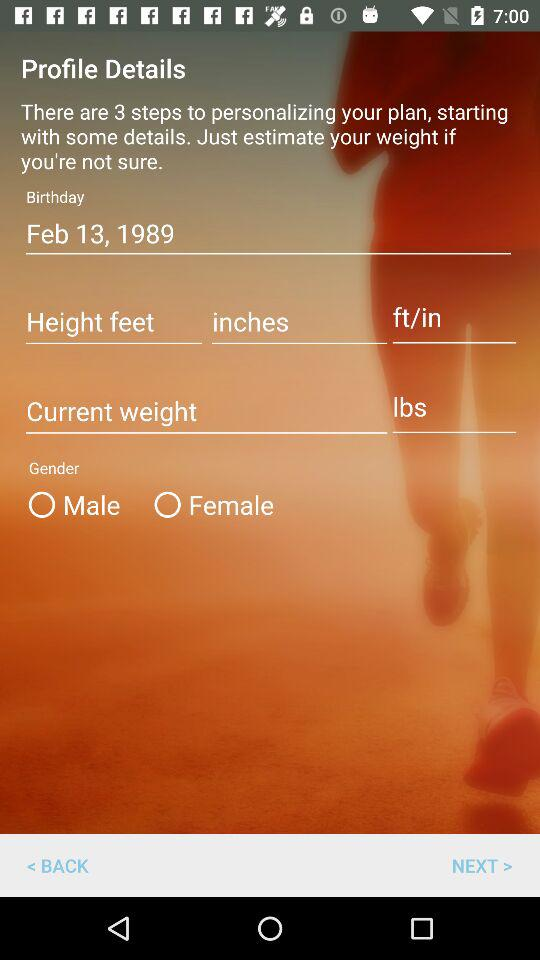How many steps are there for personalizing the plan? There are 3 steps for personalizing the plan. 